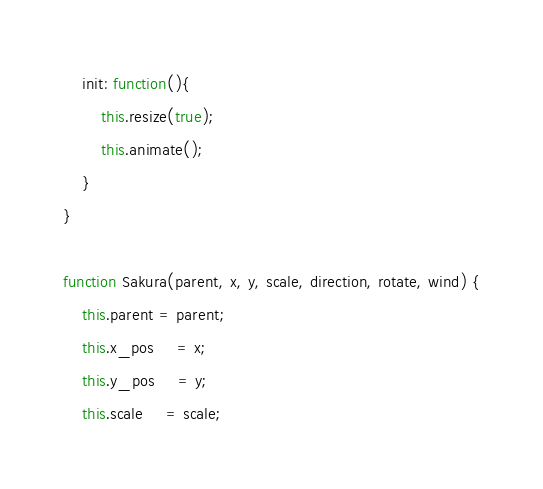Convert code to text. <code><loc_0><loc_0><loc_500><loc_500><_JavaScript_>    init: function(){
        this.resize(true);
        this.animate();
    }
}

function Sakura(parent, x, y, scale, direction, rotate, wind) {
    this.parent = parent;
    this.x_pos     = x;
    this.y_pos     = y;
    this.scale     = scale;</code> 